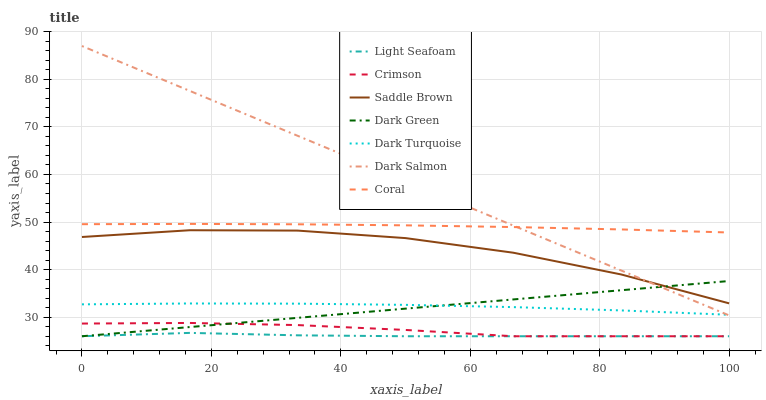Does Light Seafoam have the minimum area under the curve?
Answer yes or no. Yes. Does Dark Salmon have the maximum area under the curve?
Answer yes or no. Yes. Does Coral have the minimum area under the curve?
Answer yes or no. No. Does Coral have the maximum area under the curve?
Answer yes or no. No. Is Dark Salmon the smoothest?
Answer yes or no. Yes. Is Saddle Brown the roughest?
Answer yes or no. Yes. Is Coral the smoothest?
Answer yes or no. No. Is Coral the roughest?
Answer yes or no. No. Does Crimson have the lowest value?
Answer yes or no. Yes. Does Dark Salmon have the lowest value?
Answer yes or no. No. Does Dark Salmon have the highest value?
Answer yes or no. Yes. Does Coral have the highest value?
Answer yes or no. No. Is Dark Turquoise less than Saddle Brown?
Answer yes or no. Yes. Is Saddle Brown greater than Dark Turquoise?
Answer yes or no. Yes. Does Dark Salmon intersect Dark Turquoise?
Answer yes or no. Yes. Is Dark Salmon less than Dark Turquoise?
Answer yes or no. No. Is Dark Salmon greater than Dark Turquoise?
Answer yes or no. No. Does Dark Turquoise intersect Saddle Brown?
Answer yes or no. No. 